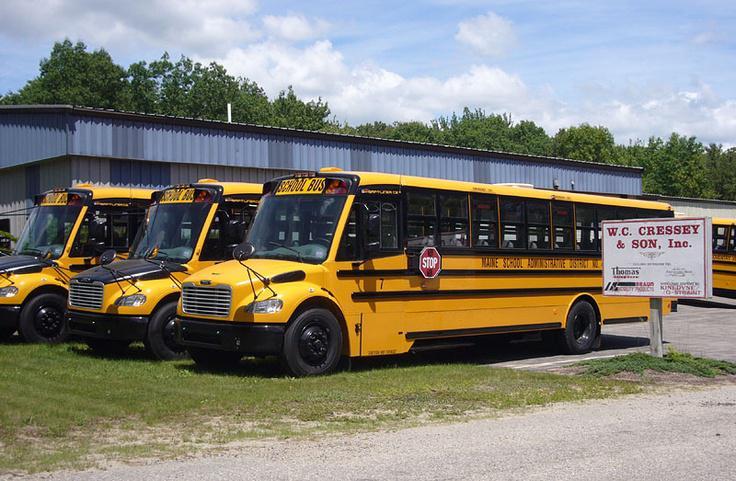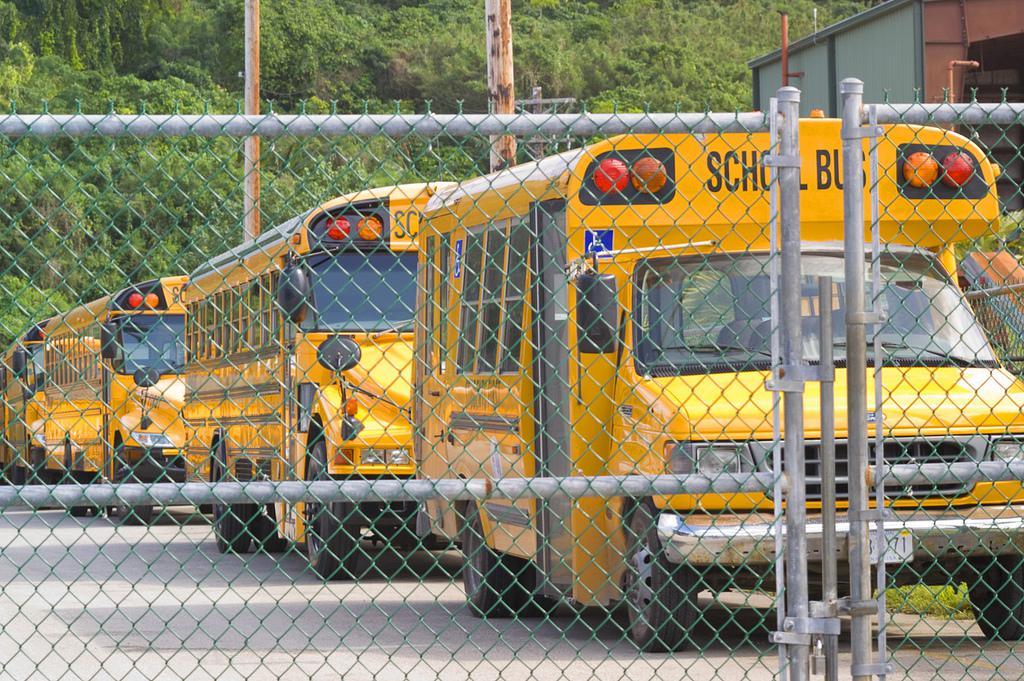The first image is the image on the left, the second image is the image on the right. Analyze the images presented: Is the assertion "The door of the bus in the image on the right is open." valid? Answer yes or no. No. The first image is the image on the left, the second image is the image on the right. Assess this claim about the two images: "The right image contains at least three school buses.". Correct or not? Answer yes or no. Yes. 